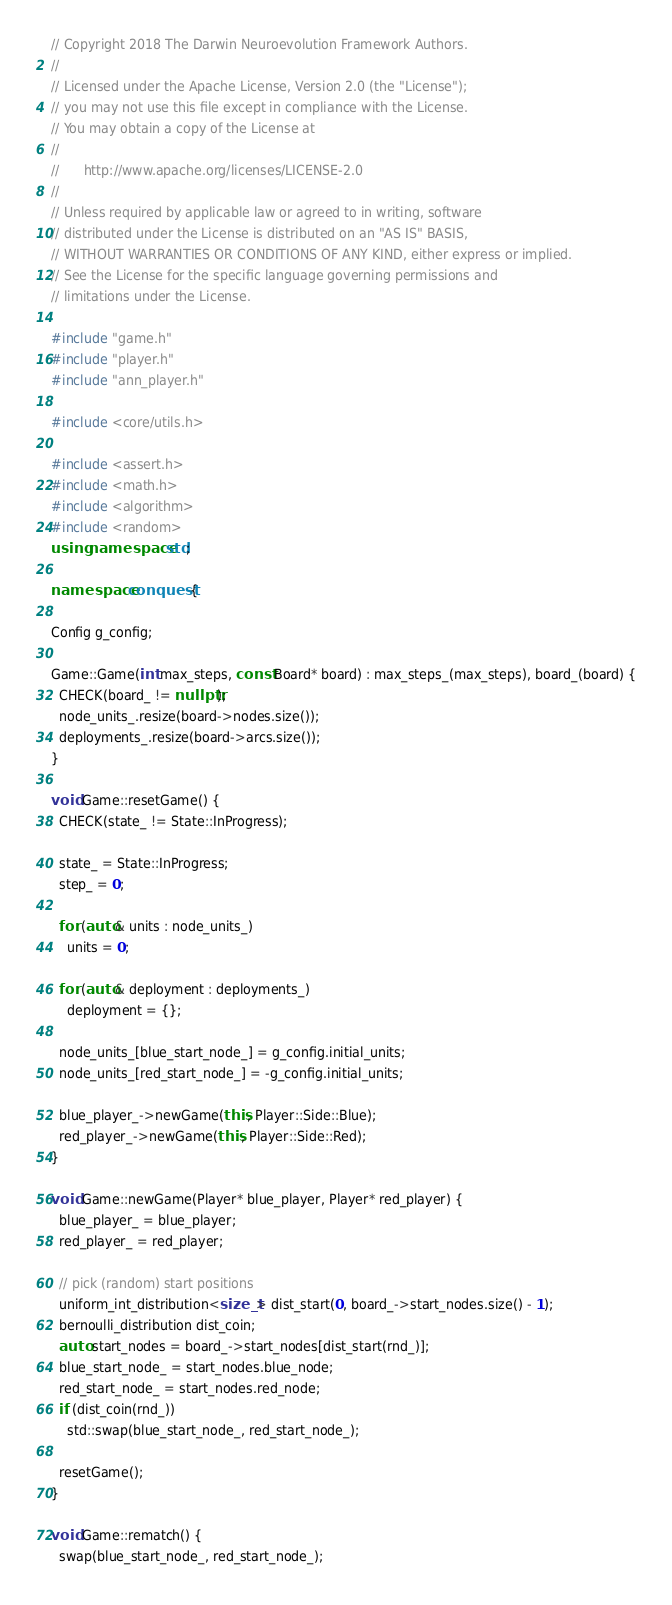<code> <loc_0><loc_0><loc_500><loc_500><_C++_>// Copyright 2018 The Darwin Neuroevolution Framework Authors.
//
// Licensed under the Apache License, Version 2.0 (the "License");
// you may not use this file except in compliance with the License.
// You may obtain a copy of the License at
//
//      http://www.apache.org/licenses/LICENSE-2.0
//
// Unless required by applicable law or agreed to in writing, software
// distributed under the License is distributed on an "AS IS" BASIS,
// WITHOUT WARRANTIES OR CONDITIONS OF ANY KIND, either express or implied.
// See the License for the specific language governing permissions and
// limitations under the License.

#include "game.h"
#include "player.h"
#include "ann_player.h"

#include <core/utils.h>

#include <assert.h>
#include <math.h>
#include <algorithm>
#include <random>
using namespace std;

namespace conquest {

Config g_config;

Game::Game(int max_steps, const Board* board) : max_steps_(max_steps), board_(board) {
  CHECK(board_ != nullptr);
  node_units_.resize(board->nodes.size());
  deployments_.resize(board->arcs.size());
}

void Game::resetGame() {
  CHECK(state_ != State::InProgress);

  state_ = State::InProgress;
  step_ = 0;

  for (auto& units : node_units_)
    units = 0;

  for (auto& deployment : deployments_)
    deployment = {};

  node_units_[blue_start_node_] = g_config.initial_units;
  node_units_[red_start_node_] = -g_config.initial_units;

  blue_player_->newGame(this, Player::Side::Blue);
  red_player_->newGame(this, Player::Side::Red);
}

void Game::newGame(Player* blue_player, Player* red_player) {
  blue_player_ = blue_player;
  red_player_ = red_player;

  // pick (random) start positions
  uniform_int_distribution<size_t> dist_start(0, board_->start_nodes.size() - 1);
  bernoulli_distribution dist_coin;
  auto start_nodes = board_->start_nodes[dist_start(rnd_)];
  blue_start_node_ = start_nodes.blue_node;
  red_start_node_ = start_nodes.red_node;
  if (dist_coin(rnd_))
    std::swap(blue_start_node_, red_start_node_);

  resetGame();
}

void Game::rematch() {
  swap(blue_start_node_, red_start_node_);</code> 